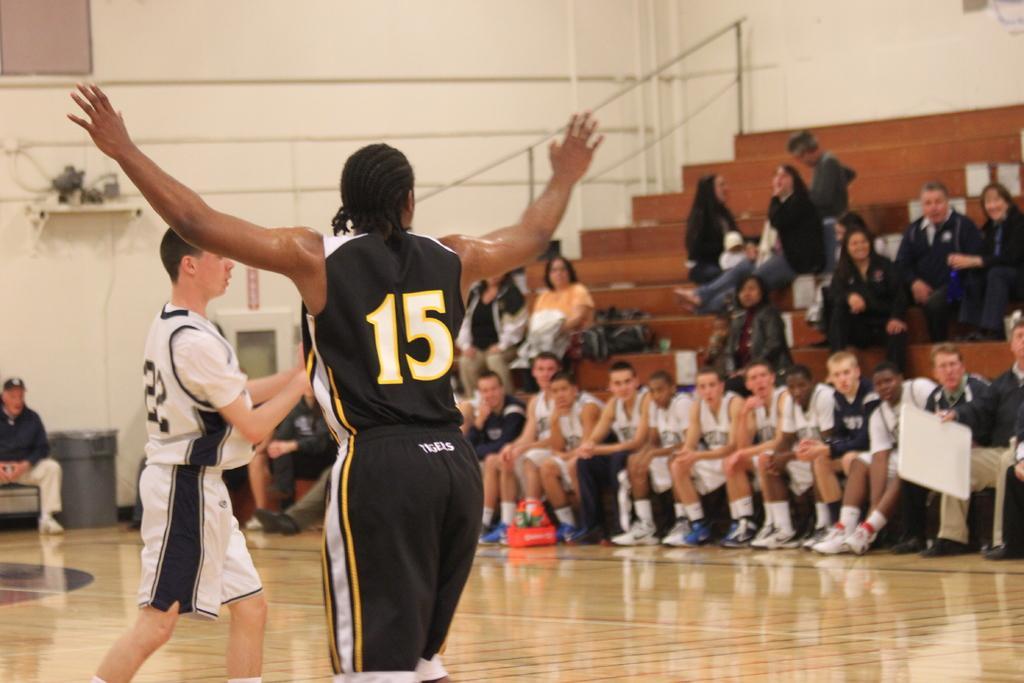Please provide a concise description of this image. In the center of the image, we can see people standing and in the background, we can see people sitting on the stairs and there is a wall. At the bottom, there is floor. 